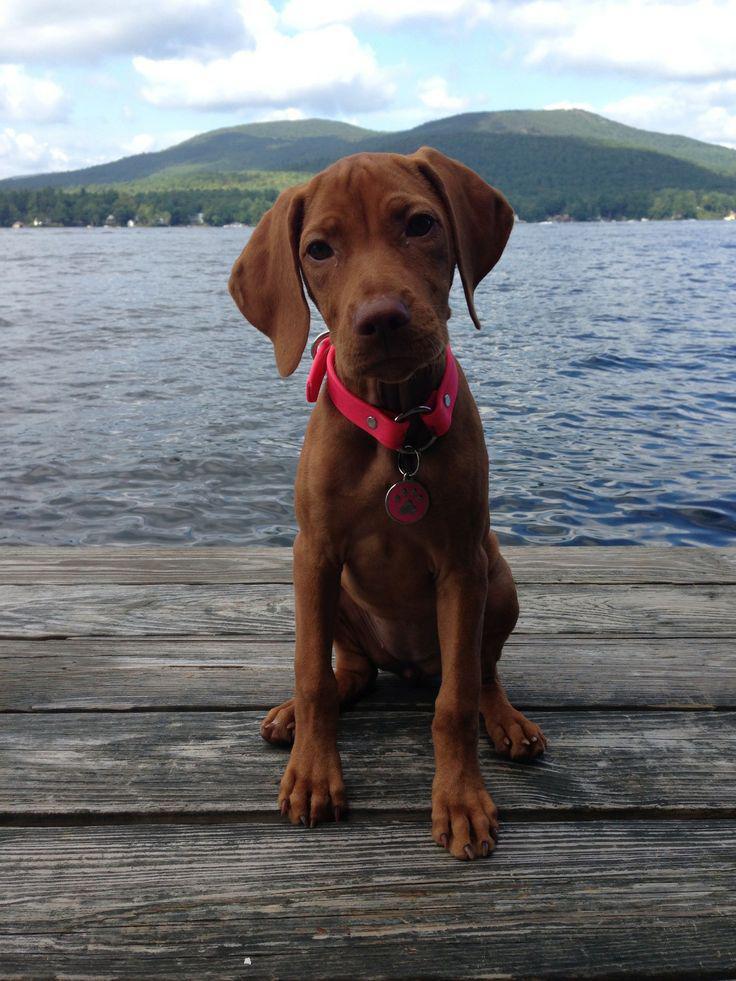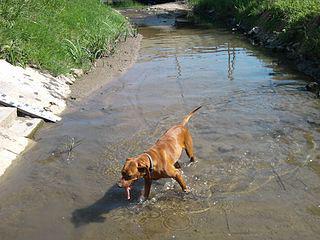The first image is the image on the left, the second image is the image on the right. Given the left and right images, does the statement "In the left image there is a brown dog sitting on the ground." hold true? Answer yes or no. Yes. The first image is the image on the left, the second image is the image on the right. For the images displayed, is the sentence "Exactly one dog is standing in water." factually correct? Answer yes or no. Yes. 